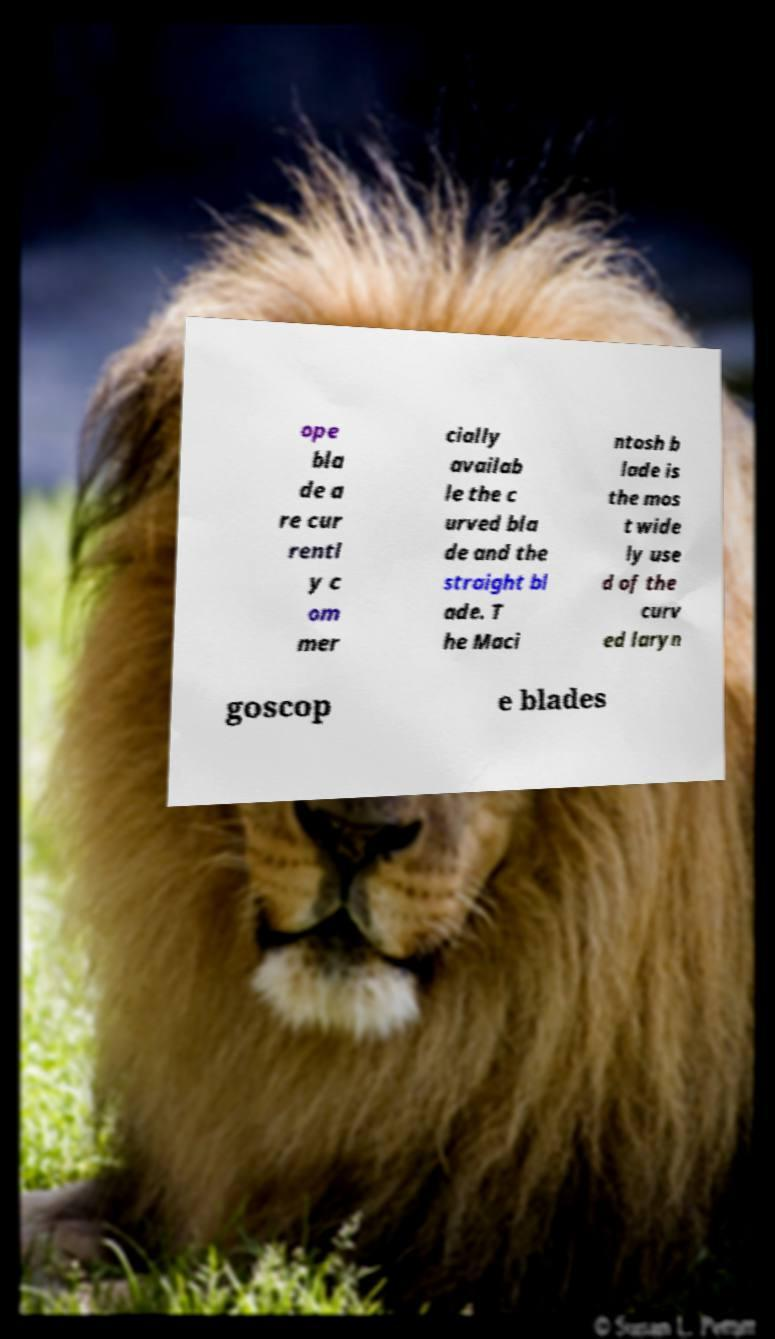Could you assist in decoding the text presented in this image and type it out clearly? ope bla de a re cur rentl y c om mer cially availab le the c urved bla de and the straight bl ade. T he Maci ntosh b lade is the mos t wide ly use d of the curv ed laryn goscop e blades 